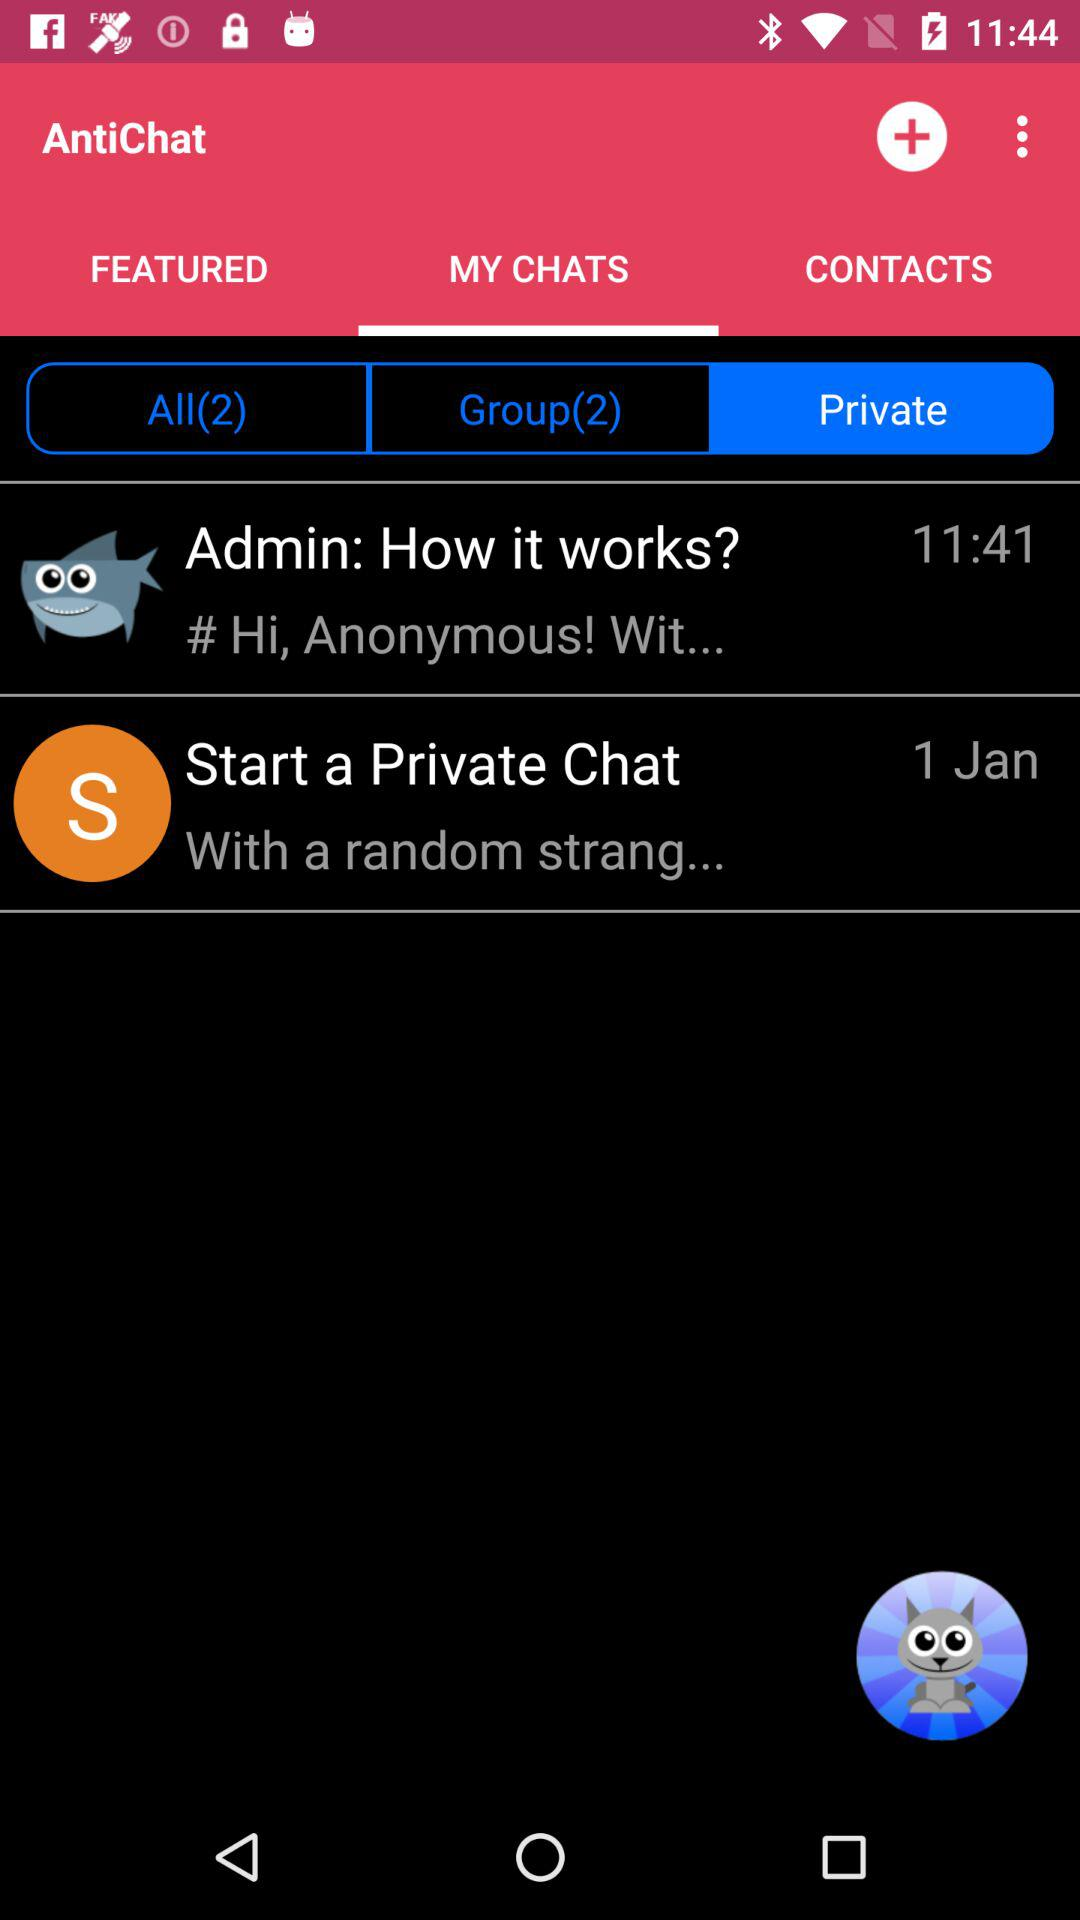What is the time mentioned for "Admin: How it works"? The mentioned time is 11:41. 